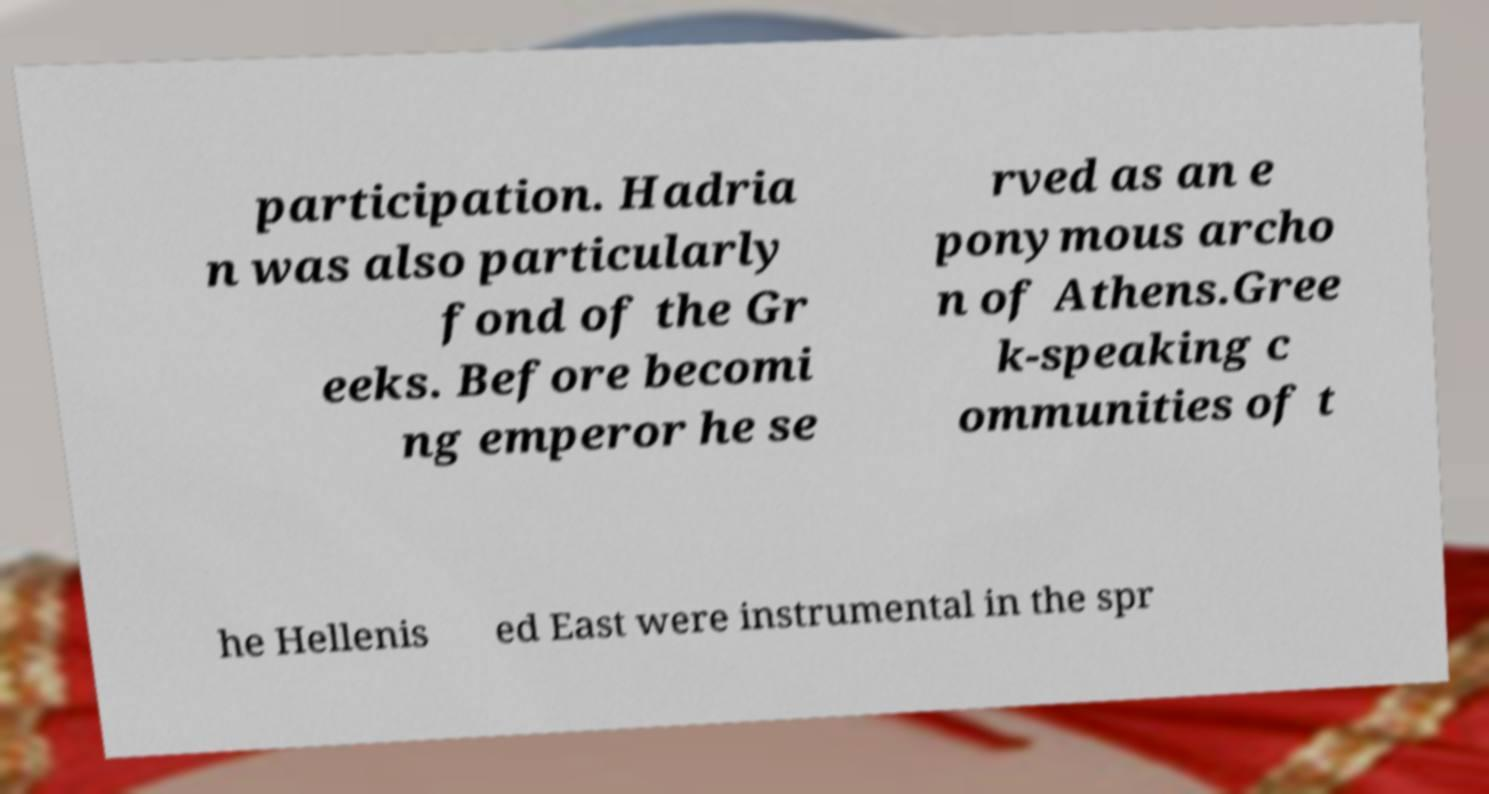Can you accurately transcribe the text from the provided image for me? participation. Hadria n was also particularly fond of the Gr eeks. Before becomi ng emperor he se rved as an e ponymous archo n of Athens.Gree k-speaking c ommunities of t he Hellenis ed East were instrumental in the spr 